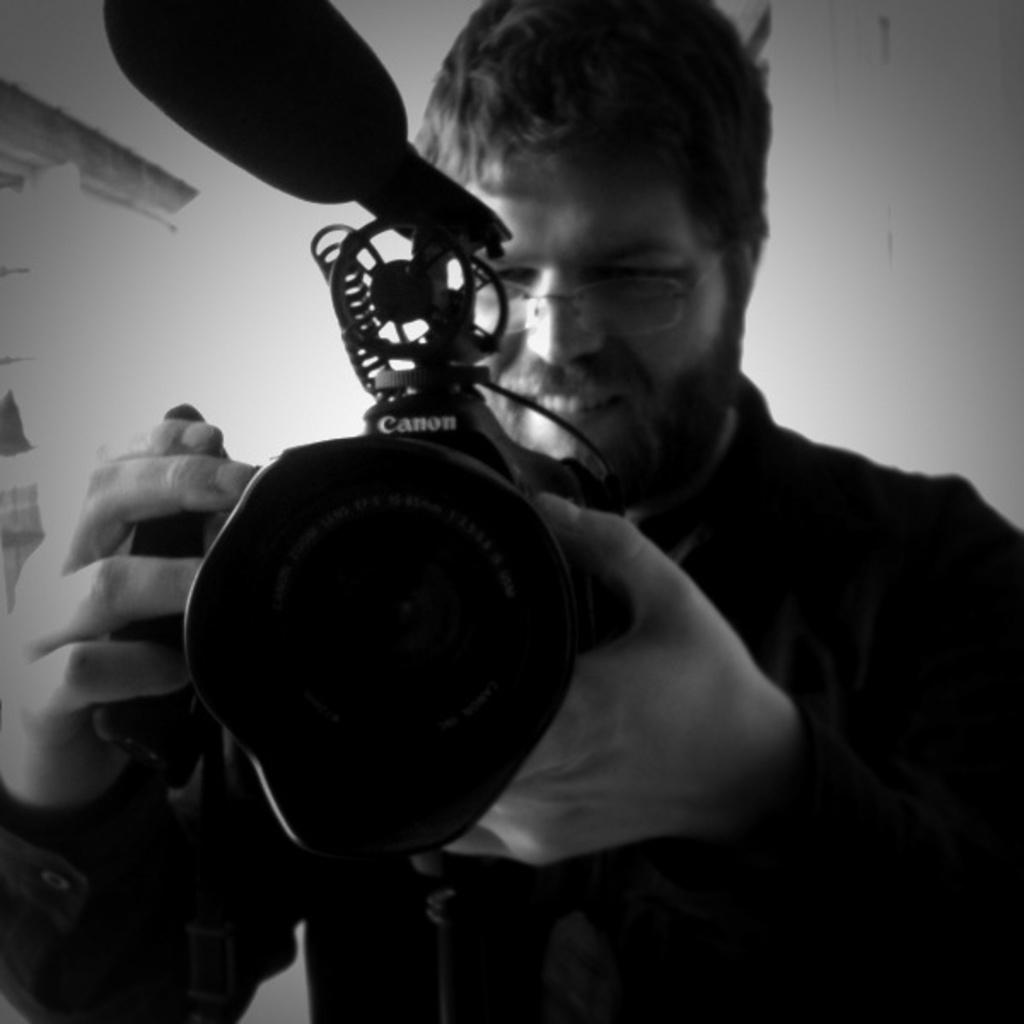What is the color scheme of the image? The image is black and white. What can be seen in the image? There is a man standing in the image. What is the man holding? The man is holding a camera. What other object is present in the image? There is an object that resembles a microphone (mike) in the image. How many pizzas are being served in the image? There are no pizzas present in the image. What type of button is the man wearing in the image? There is no button visible on the man in the image. 